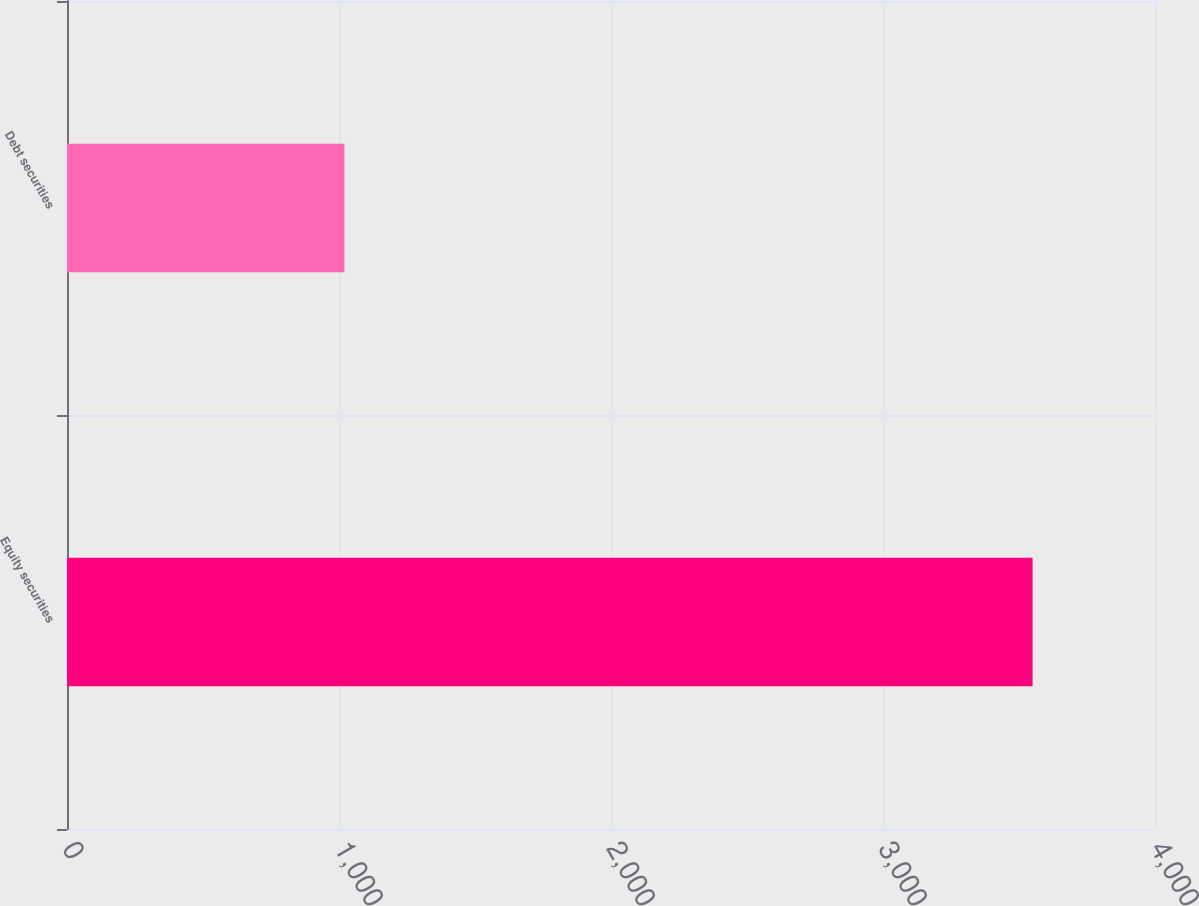Convert chart to OTSL. <chart><loc_0><loc_0><loc_500><loc_500><bar_chart><fcel>Equity securities<fcel>Debt securities<nl><fcel>3550<fcel>1020<nl></chart> 